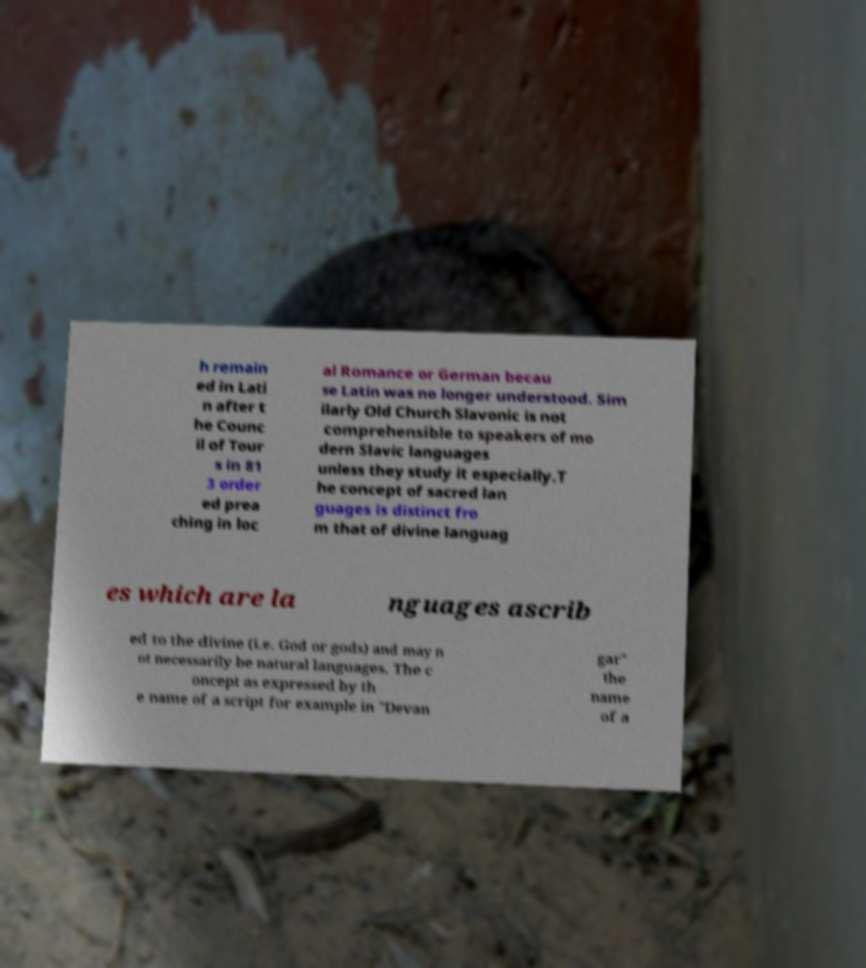What messages or text are displayed in this image? I need them in a readable, typed format. h remain ed in Lati n after t he Counc il of Tour s in 81 3 order ed prea ching in loc al Romance or German becau se Latin was no longer understood. Sim ilarly Old Church Slavonic is not comprehensible to speakers of mo dern Slavic languages unless they study it especially.T he concept of sacred lan guages is distinct fro m that of divine languag es which are la nguages ascrib ed to the divine (i.e. God or gods) and may n ot necessarily be natural languages. The c oncept as expressed by th e name of a script for example in "Devan gar" the name of a 